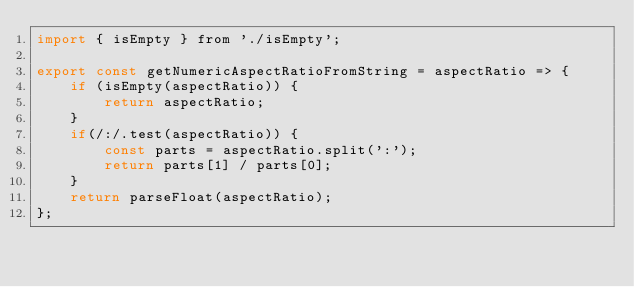Convert code to text. <code><loc_0><loc_0><loc_500><loc_500><_JavaScript_>import { isEmpty } from './isEmpty';

export const getNumericAspectRatioFromString = aspectRatio => {
    if (isEmpty(aspectRatio)) {
        return aspectRatio;
    }
    if(/:/.test(aspectRatio)) {
        const parts = aspectRatio.split(':');
        return parts[1] / parts[0];
    }
    return parseFloat(aspectRatio);
};</code> 